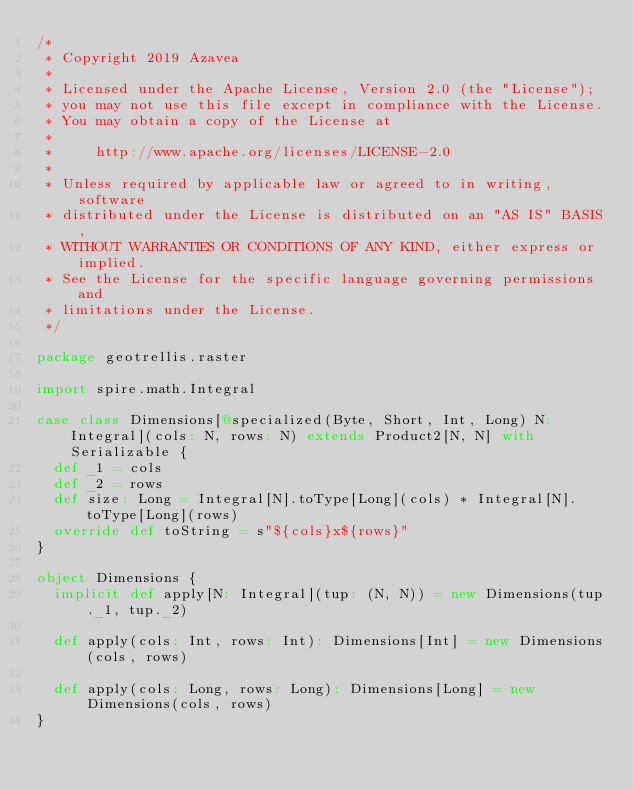Convert code to text. <code><loc_0><loc_0><loc_500><loc_500><_Scala_>/*
 * Copyright 2019 Azavea
 *
 * Licensed under the Apache License, Version 2.0 (the "License");
 * you may not use this file except in compliance with the License.
 * You may obtain a copy of the License at
 *
 *     http://www.apache.org/licenses/LICENSE-2.0
 *
 * Unless required by applicable law or agreed to in writing, software
 * distributed under the License is distributed on an "AS IS" BASIS,
 * WITHOUT WARRANTIES OR CONDITIONS OF ANY KIND, either express or implied.
 * See the License for the specific language governing permissions and
 * limitations under the License.
 */

package geotrellis.raster

import spire.math.Integral

case class Dimensions[@specialized(Byte, Short, Int, Long) N: Integral](cols: N, rows: N) extends Product2[N, N] with Serializable {
  def _1 = cols
  def _2 = rows
  def size: Long = Integral[N].toType[Long](cols) * Integral[N].toType[Long](rows)
  override def toString = s"${cols}x${rows}"
}

object Dimensions {
  implicit def apply[N: Integral](tup: (N, N)) = new Dimensions(tup._1, tup._2)

  def apply(cols: Int, rows: Int): Dimensions[Int] = new Dimensions(cols, rows)

  def apply(cols: Long, rows: Long): Dimensions[Long] = new Dimensions(cols, rows)
}
</code> 